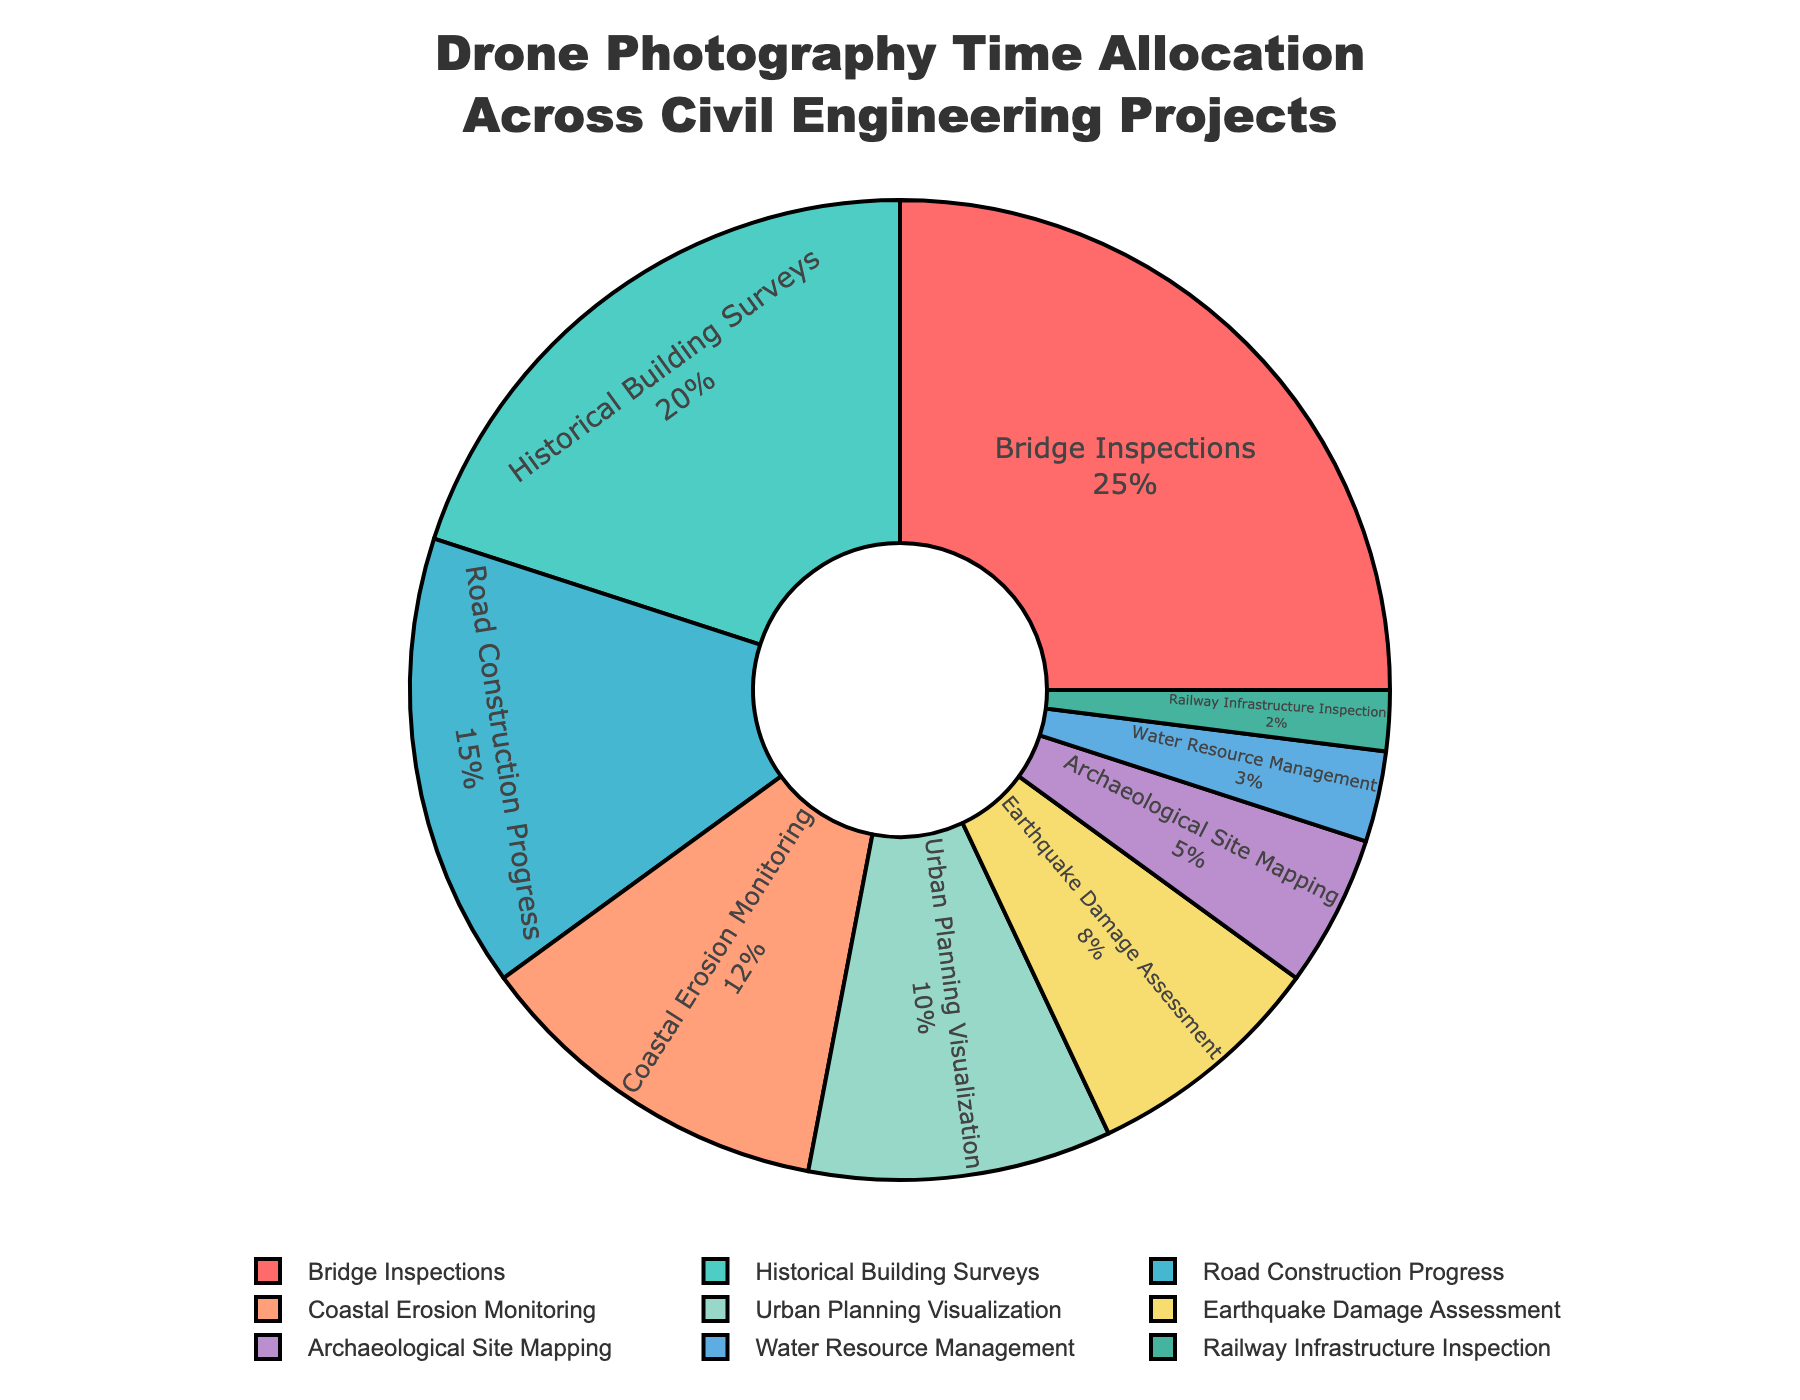Which project type has the highest allocation of drone photography time? According to the pie chart, the segment with the largest percentage represents the project type with the highest allocation of drone photography time. The largest segment is for Bridge Inspections.
Answer: Bridge Inspections What's the combined allocation percentage for Historical Building Surveys and Archaeological Site Mapping? To find the combined allocation, we add the percentages for Historical Building Surveys (20%) and Archaeological Site Mapping (5%). So, 20% + 5% = 25%.
Answer: 25% Which project types allocate less than 10% of drone photography time? By examining the segments, we identify the project types with percentages less than 10%. They are Earthquake Damage Assessment (8%), Archaeological Site Mapping (5%), Water Resource Management (3%), and Railway Infrastructure Inspection (2%).
Answer: Earthquake Damage Assessment, Archaeological Site Mapping, Water Resource Management, Railway Infrastructure Inspection How much more time is allocated to Bridge Inspections than Water Resource Management? The allocation for Bridge Inspections is 25% and for Water Resource Management is 3%. The difference between them is 25% - 3% = 22%.
Answer: 22% What is the average time allocation for Urban Planning Visualization and Coastal Erosion Monitoring? To find the average, we add the percentages for Urban Planning Visualization (10%) and Coastal Erosion Monitoring (12%), and then divide by 2. (10% + 12%) / 2 = 11%.
Answer: 11% Is the time allocated to Road Construction Progress greater than or less than the time allocated to Earthquake Damage Assessment? By comparing the percentages, we see that Road Construction Progress (15%) has a larger allocation than Earthquake Damage Assessment (8%).
Answer: Greater What is the combined percentage allocation for Road Construction Progress, Coastal Erosion Monitoring, and Urban Planning Visualization? Summing up the percentages: Road Construction Progress (15%), Coastal Erosion Monitoring (12%), and Urban Planning Visualization (10%): 15% + 12% + 10% = 37%.
Answer: 37% Which project type is represented by the purple segment? The purple segment corresponds to the percentage allocation for Archaeological Site Mapping, which is 5%.
Answer: Archaeological Site Mapping How many project types allocate more than 15% of drone photography time? By examining the segments, we identify the project types with allocations more than 15%, which are Bridge Inspections (25%) and Historical Building Surveys (20%).
Answer: 2 